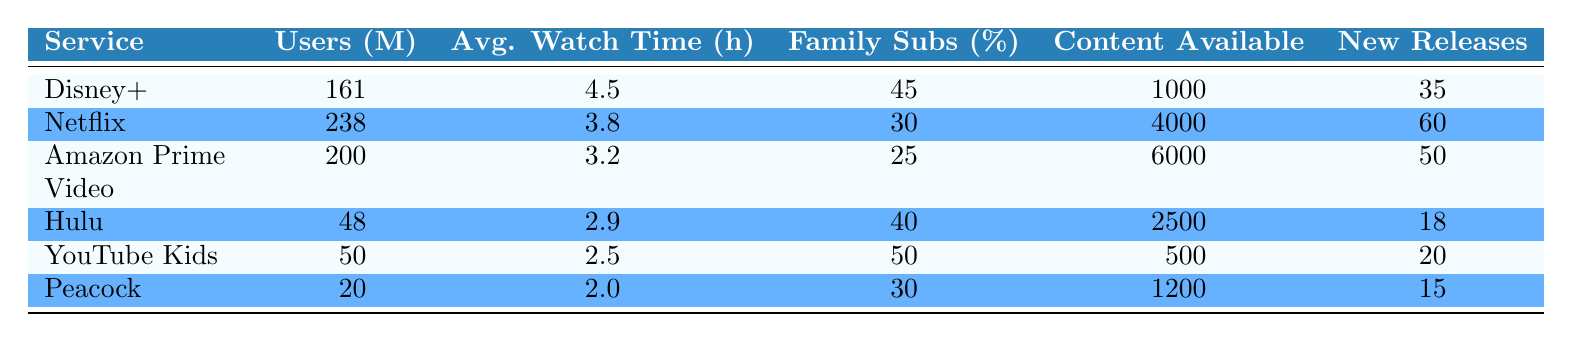What is the reported number of users for Disney+? The table lists the reported users for Disney+ as 161 million.
Answer: 161 million Which streaming service has the highest average watch time per user? By comparing the average watch time per user across services, Disney+ with 4.5 hours has the highest average.
Answer: Disney+ What percentage of subscriptions for YouTube Kids are family subscriptions? The table indicates that YouTube Kids has 50% of its subscriptions categorized as family subscriptions.
Answer: 50% Which service had the lowest number of new releases in Q3 2023? Comparing the new releases for all services listed, Peacock had the lowest with 15 new releases.
Answer: Peacock Calculate the total number of users for Netflix and Amazon Prime Video combined. By adding the reported users for Netflix (238 million) and Amazon Prime Video (200 million), the total is 238 + 200 = 438 million.
Answer: 438 million Is the percentage of family subscriptions for Hulu greater than that for Amazon Prime Video? The table shows Hulu with 40% family subscriptions and Amazon Prime Video with 25%, so it's true that Hulu has a greater percentage.
Answer: Yes What is the average reported user count for all the streaming services listed? To find the average, sum the reported users (161 + 238 + 200 + 48 + 50 + 20 = 717 million) and divide by the number of services (6), resulting in 717 / 6 = 119.5 million.
Answer: 119.5 million Are there more family subscriptions in Disney+ than in Hulu? Disney+ has 45% family subscriptions while Hulu has 40%, indicating more family subscriptions in Disney+.
Answer: Yes Which service has the most content available? By reviewing the content available, Amazon Prime Video has the most with 6000 titles.
Answer: Amazon Prime Video 